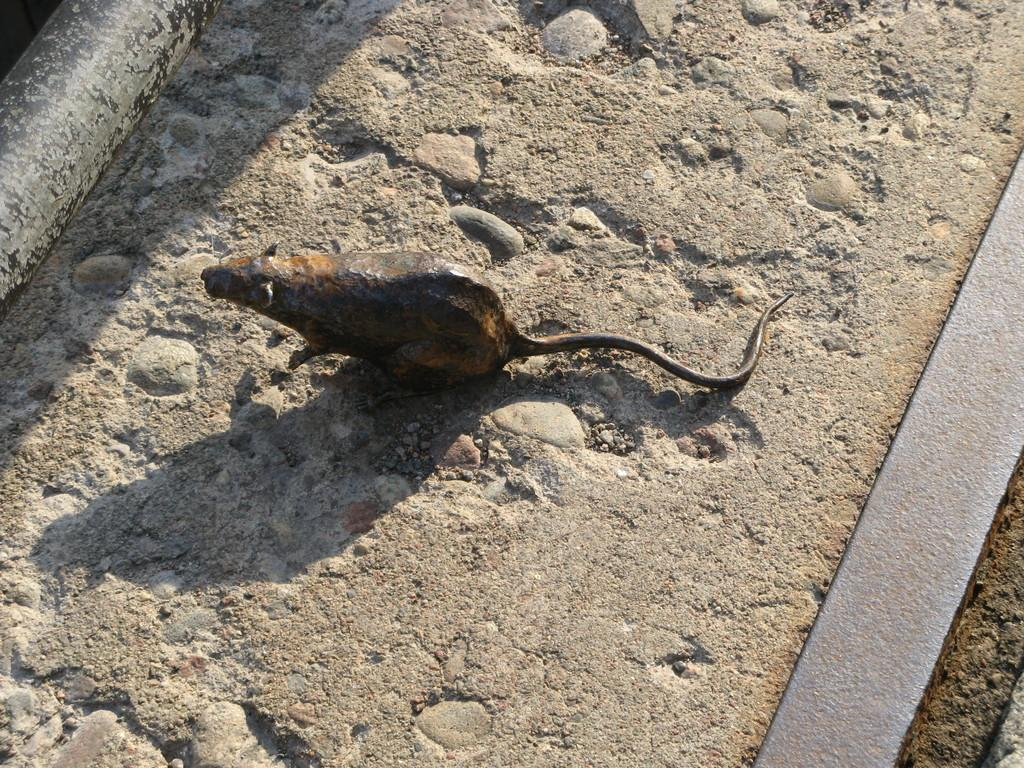What is the main subject of the image? There is a sculpture of a rat in the center of the image. What is located at the bottom of the image? There is a road at the bottom of the image. What type of sheet is draped over the rat sculpture in the image? There is no sheet present in the image; it only features a sculpture of a rat and a road. 